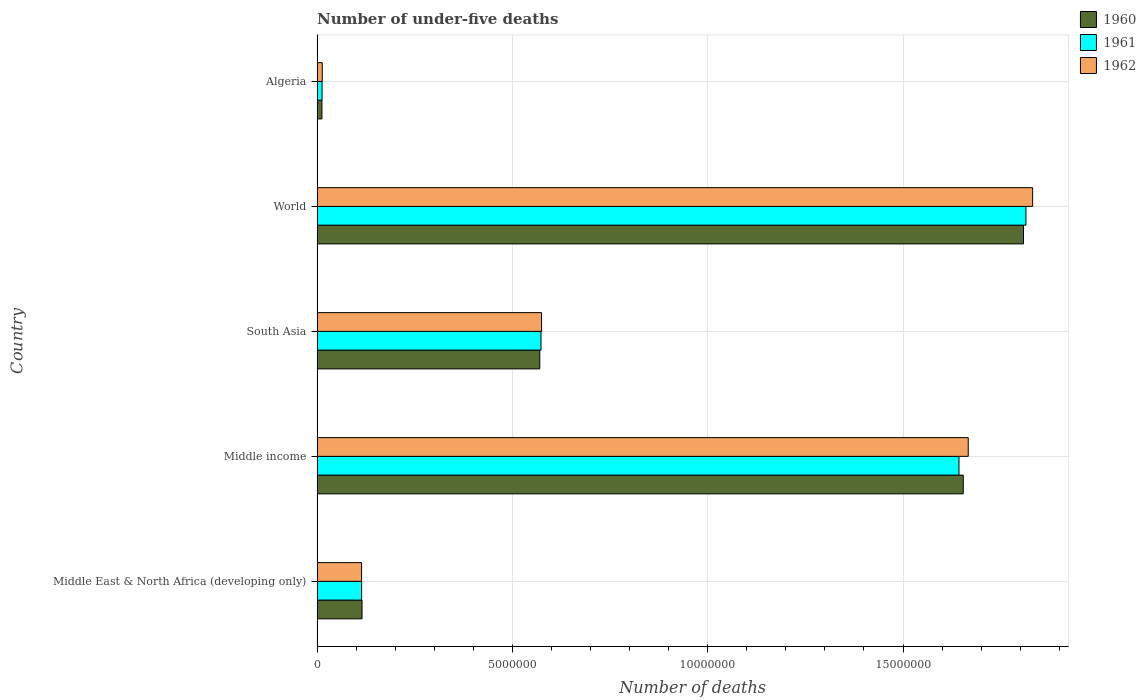How many groups of bars are there?
Make the answer very short. 5. Are the number of bars per tick equal to the number of legend labels?
Make the answer very short. Yes. How many bars are there on the 2nd tick from the top?
Offer a terse response. 3. What is the label of the 1st group of bars from the top?
Your answer should be compact. Algeria. In how many cases, is the number of bars for a given country not equal to the number of legend labels?
Keep it short and to the point. 0. What is the number of under-five deaths in 1961 in South Asia?
Offer a terse response. 5.73e+06. Across all countries, what is the maximum number of under-five deaths in 1960?
Your answer should be very brief. 1.81e+07. Across all countries, what is the minimum number of under-five deaths in 1962?
Keep it short and to the point. 1.33e+05. In which country was the number of under-five deaths in 1961 maximum?
Provide a succinct answer. World. In which country was the number of under-five deaths in 1960 minimum?
Offer a very short reply. Algeria. What is the total number of under-five deaths in 1960 in the graph?
Provide a short and direct response. 4.16e+07. What is the difference between the number of under-five deaths in 1962 in Middle East & North Africa (developing only) and that in South Asia?
Your answer should be very brief. -4.61e+06. What is the difference between the number of under-five deaths in 1962 in Middle East & North Africa (developing only) and the number of under-five deaths in 1961 in World?
Provide a short and direct response. -1.70e+07. What is the average number of under-five deaths in 1961 per country?
Your answer should be compact. 8.32e+06. What is the difference between the number of under-five deaths in 1961 and number of under-five deaths in 1960 in Algeria?
Give a very brief answer. 2789. In how many countries, is the number of under-five deaths in 1962 greater than 8000000 ?
Ensure brevity in your answer.  2. What is the ratio of the number of under-five deaths in 1962 in Algeria to that in World?
Ensure brevity in your answer.  0.01. Is the number of under-five deaths in 1962 in Algeria less than that in South Asia?
Offer a terse response. Yes. What is the difference between the highest and the second highest number of under-five deaths in 1962?
Give a very brief answer. 1.65e+06. What is the difference between the highest and the lowest number of under-five deaths in 1960?
Your answer should be very brief. 1.80e+07. What does the 3rd bar from the bottom in Algeria represents?
Make the answer very short. 1962. Is it the case that in every country, the sum of the number of under-five deaths in 1962 and number of under-five deaths in 1961 is greater than the number of under-five deaths in 1960?
Your answer should be very brief. Yes. How many countries are there in the graph?
Give a very brief answer. 5. What is the difference between two consecutive major ticks on the X-axis?
Offer a terse response. 5.00e+06. Are the values on the major ticks of X-axis written in scientific E-notation?
Offer a terse response. No. Does the graph contain any zero values?
Provide a short and direct response. No. Does the graph contain grids?
Your response must be concise. Yes. How many legend labels are there?
Keep it short and to the point. 3. How are the legend labels stacked?
Ensure brevity in your answer.  Vertical. What is the title of the graph?
Your response must be concise. Number of under-five deaths. What is the label or title of the X-axis?
Your answer should be very brief. Number of deaths. What is the label or title of the Y-axis?
Your response must be concise. Country. What is the Number of deaths in 1960 in Middle East & North Africa (developing only)?
Keep it short and to the point. 1.15e+06. What is the Number of deaths of 1961 in Middle East & North Africa (developing only)?
Give a very brief answer. 1.14e+06. What is the Number of deaths of 1962 in Middle East & North Africa (developing only)?
Provide a succinct answer. 1.14e+06. What is the Number of deaths of 1960 in Middle income?
Provide a succinct answer. 1.65e+07. What is the Number of deaths of 1961 in Middle income?
Offer a terse response. 1.64e+07. What is the Number of deaths in 1962 in Middle income?
Your answer should be compact. 1.67e+07. What is the Number of deaths of 1960 in South Asia?
Make the answer very short. 5.70e+06. What is the Number of deaths in 1961 in South Asia?
Your response must be concise. 5.73e+06. What is the Number of deaths in 1962 in South Asia?
Offer a very short reply. 5.75e+06. What is the Number of deaths of 1960 in World?
Your answer should be compact. 1.81e+07. What is the Number of deaths in 1961 in World?
Give a very brief answer. 1.81e+07. What is the Number of deaths in 1962 in World?
Ensure brevity in your answer.  1.83e+07. What is the Number of deaths of 1960 in Algeria?
Ensure brevity in your answer.  1.25e+05. What is the Number of deaths of 1961 in Algeria?
Your answer should be compact. 1.28e+05. What is the Number of deaths of 1962 in Algeria?
Give a very brief answer. 1.33e+05. Across all countries, what is the maximum Number of deaths in 1960?
Your answer should be compact. 1.81e+07. Across all countries, what is the maximum Number of deaths of 1961?
Provide a short and direct response. 1.81e+07. Across all countries, what is the maximum Number of deaths in 1962?
Your answer should be compact. 1.83e+07. Across all countries, what is the minimum Number of deaths of 1960?
Your answer should be compact. 1.25e+05. Across all countries, what is the minimum Number of deaths in 1961?
Provide a succinct answer. 1.28e+05. Across all countries, what is the minimum Number of deaths of 1962?
Provide a short and direct response. 1.33e+05. What is the total Number of deaths of 1960 in the graph?
Offer a terse response. 4.16e+07. What is the total Number of deaths in 1961 in the graph?
Offer a terse response. 4.16e+07. What is the total Number of deaths in 1962 in the graph?
Provide a short and direct response. 4.20e+07. What is the difference between the Number of deaths of 1960 in Middle East & North Africa (developing only) and that in Middle income?
Provide a short and direct response. -1.54e+07. What is the difference between the Number of deaths in 1961 in Middle East & North Africa (developing only) and that in Middle income?
Provide a short and direct response. -1.53e+07. What is the difference between the Number of deaths in 1962 in Middle East & North Africa (developing only) and that in Middle income?
Provide a short and direct response. -1.55e+07. What is the difference between the Number of deaths in 1960 in Middle East & North Africa (developing only) and that in South Asia?
Ensure brevity in your answer.  -4.55e+06. What is the difference between the Number of deaths in 1961 in Middle East & North Africa (developing only) and that in South Asia?
Your answer should be compact. -4.59e+06. What is the difference between the Number of deaths of 1962 in Middle East & North Africa (developing only) and that in South Asia?
Your answer should be compact. -4.61e+06. What is the difference between the Number of deaths of 1960 in Middle East & North Africa (developing only) and that in World?
Offer a terse response. -1.69e+07. What is the difference between the Number of deaths in 1961 in Middle East & North Africa (developing only) and that in World?
Your response must be concise. -1.70e+07. What is the difference between the Number of deaths of 1962 in Middle East & North Africa (developing only) and that in World?
Make the answer very short. -1.72e+07. What is the difference between the Number of deaths in 1960 in Middle East & North Africa (developing only) and that in Algeria?
Provide a short and direct response. 1.03e+06. What is the difference between the Number of deaths of 1961 in Middle East & North Africa (developing only) and that in Algeria?
Your answer should be compact. 1.01e+06. What is the difference between the Number of deaths in 1962 in Middle East & North Africa (developing only) and that in Algeria?
Keep it short and to the point. 1.01e+06. What is the difference between the Number of deaths in 1960 in Middle income and that in South Asia?
Make the answer very short. 1.08e+07. What is the difference between the Number of deaths of 1961 in Middle income and that in South Asia?
Make the answer very short. 1.07e+07. What is the difference between the Number of deaths in 1962 in Middle income and that in South Asia?
Your response must be concise. 1.09e+07. What is the difference between the Number of deaths of 1960 in Middle income and that in World?
Offer a very short reply. -1.54e+06. What is the difference between the Number of deaths in 1961 in Middle income and that in World?
Provide a short and direct response. -1.71e+06. What is the difference between the Number of deaths of 1962 in Middle income and that in World?
Keep it short and to the point. -1.65e+06. What is the difference between the Number of deaths in 1960 in Middle income and that in Algeria?
Keep it short and to the point. 1.64e+07. What is the difference between the Number of deaths in 1961 in Middle income and that in Algeria?
Your answer should be compact. 1.63e+07. What is the difference between the Number of deaths of 1962 in Middle income and that in Algeria?
Ensure brevity in your answer.  1.65e+07. What is the difference between the Number of deaths in 1960 in South Asia and that in World?
Provide a succinct answer. -1.24e+07. What is the difference between the Number of deaths in 1961 in South Asia and that in World?
Give a very brief answer. -1.24e+07. What is the difference between the Number of deaths in 1962 in South Asia and that in World?
Your answer should be compact. -1.26e+07. What is the difference between the Number of deaths in 1960 in South Asia and that in Algeria?
Ensure brevity in your answer.  5.58e+06. What is the difference between the Number of deaths in 1961 in South Asia and that in Algeria?
Provide a short and direct response. 5.60e+06. What is the difference between the Number of deaths in 1962 in South Asia and that in Algeria?
Offer a terse response. 5.61e+06. What is the difference between the Number of deaths of 1960 in World and that in Algeria?
Give a very brief answer. 1.80e+07. What is the difference between the Number of deaths in 1961 in World and that in Algeria?
Give a very brief answer. 1.80e+07. What is the difference between the Number of deaths in 1962 in World and that in Algeria?
Make the answer very short. 1.82e+07. What is the difference between the Number of deaths in 1960 in Middle East & North Africa (developing only) and the Number of deaths in 1961 in Middle income?
Your answer should be very brief. -1.53e+07. What is the difference between the Number of deaths in 1960 in Middle East & North Africa (developing only) and the Number of deaths in 1962 in Middle income?
Make the answer very short. -1.55e+07. What is the difference between the Number of deaths of 1961 in Middle East & North Africa (developing only) and the Number of deaths of 1962 in Middle income?
Offer a very short reply. -1.55e+07. What is the difference between the Number of deaths in 1960 in Middle East & North Africa (developing only) and the Number of deaths in 1961 in South Asia?
Give a very brief answer. -4.58e+06. What is the difference between the Number of deaths of 1960 in Middle East & North Africa (developing only) and the Number of deaths of 1962 in South Asia?
Make the answer very short. -4.59e+06. What is the difference between the Number of deaths of 1961 in Middle East & North Africa (developing only) and the Number of deaths of 1962 in South Asia?
Provide a succinct answer. -4.61e+06. What is the difference between the Number of deaths in 1960 in Middle East & North Africa (developing only) and the Number of deaths in 1961 in World?
Offer a very short reply. -1.70e+07. What is the difference between the Number of deaths in 1960 in Middle East & North Africa (developing only) and the Number of deaths in 1962 in World?
Your answer should be compact. -1.72e+07. What is the difference between the Number of deaths of 1961 in Middle East & North Africa (developing only) and the Number of deaths of 1962 in World?
Give a very brief answer. -1.72e+07. What is the difference between the Number of deaths in 1960 in Middle East & North Africa (developing only) and the Number of deaths in 1961 in Algeria?
Make the answer very short. 1.02e+06. What is the difference between the Number of deaths in 1960 in Middle East & North Africa (developing only) and the Number of deaths in 1962 in Algeria?
Keep it short and to the point. 1.02e+06. What is the difference between the Number of deaths in 1961 in Middle East & North Africa (developing only) and the Number of deaths in 1962 in Algeria?
Provide a succinct answer. 1.01e+06. What is the difference between the Number of deaths in 1960 in Middle income and the Number of deaths in 1961 in South Asia?
Offer a very short reply. 1.08e+07. What is the difference between the Number of deaths in 1960 in Middle income and the Number of deaths in 1962 in South Asia?
Your answer should be very brief. 1.08e+07. What is the difference between the Number of deaths in 1961 in Middle income and the Number of deaths in 1962 in South Asia?
Provide a short and direct response. 1.07e+07. What is the difference between the Number of deaths of 1960 in Middle income and the Number of deaths of 1961 in World?
Offer a terse response. -1.60e+06. What is the difference between the Number of deaths of 1960 in Middle income and the Number of deaths of 1962 in World?
Your answer should be very brief. -1.78e+06. What is the difference between the Number of deaths of 1961 in Middle income and the Number of deaths of 1962 in World?
Your answer should be very brief. -1.89e+06. What is the difference between the Number of deaths of 1960 in Middle income and the Number of deaths of 1961 in Algeria?
Make the answer very short. 1.64e+07. What is the difference between the Number of deaths of 1960 in Middle income and the Number of deaths of 1962 in Algeria?
Provide a succinct answer. 1.64e+07. What is the difference between the Number of deaths of 1961 in Middle income and the Number of deaths of 1962 in Algeria?
Keep it short and to the point. 1.63e+07. What is the difference between the Number of deaths of 1960 in South Asia and the Number of deaths of 1961 in World?
Provide a short and direct response. -1.24e+07. What is the difference between the Number of deaths of 1960 in South Asia and the Number of deaths of 1962 in World?
Offer a very short reply. -1.26e+07. What is the difference between the Number of deaths in 1961 in South Asia and the Number of deaths in 1962 in World?
Keep it short and to the point. -1.26e+07. What is the difference between the Number of deaths of 1960 in South Asia and the Number of deaths of 1961 in Algeria?
Give a very brief answer. 5.57e+06. What is the difference between the Number of deaths of 1960 in South Asia and the Number of deaths of 1962 in Algeria?
Ensure brevity in your answer.  5.57e+06. What is the difference between the Number of deaths of 1961 in South Asia and the Number of deaths of 1962 in Algeria?
Ensure brevity in your answer.  5.60e+06. What is the difference between the Number of deaths of 1960 in World and the Number of deaths of 1961 in Algeria?
Provide a succinct answer. 1.80e+07. What is the difference between the Number of deaths in 1960 in World and the Number of deaths in 1962 in Algeria?
Provide a short and direct response. 1.80e+07. What is the difference between the Number of deaths of 1961 in World and the Number of deaths of 1962 in Algeria?
Keep it short and to the point. 1.80e+07. What is the average Number of deaths of 1960 per country?
Ensure brevity in your answer.  8.32e+06. What is the average Number of deaths of 1961 per country?
Provide a succinct answer. 8.32e+06. What is the average Number of deaths in 1962 per country?
Ensure brevity in your answer.  8.40e+06. What is the difference between the Number of deaths in 1960 and Number of deaths in 1961 in Middle East & North Africa (developing only)?
Your answer should be compact. 1.05e+04. What is the difference between the Number of deaths in 1960 and Number of deaths in 1962 in Middle East & North Africa (developing only)?
Provide a succinct answer. 1.18e+04. What is the difference between the Number of deaths in 1961 and Number of deaths in 1962 in Middle East & North Africa (developing only)?
Make the answer very short. 1336. What is the difference between the Number of deaths of 1960 and Number of deaths of 1961 in Middle income?
Your answer should be very brief. 1.10e+05. What is the difference between the Number of deaths of 1960 and Number of deaths of 1962 in Middle income?
Keep it short and to the point. -1.27e+05. What is the difference between the Number of deaths in 1961 and Number of deaths in 1962 in Middle income?
Provide a short and direct response. -2.37e+05. What is the difference between the Number of deaths of 1960 and Number of deaths of 1961 in South Asia?
Your response must be concise. -3.16e+04. What is the difference between the Number of deaths in 1960 and Number of deaths in 1962 in South Asia?
Offer a terse response. -4.54e+04. What is the difference between the Number of deaths in 1961 and Number of deaths in 1962 in South Asia?
Provide a short and direct response. -1.37e+04. What is the difference between the Number of deaths in 1960 and Number of deaths in 1961 in World?
Keep it short and to the point. -6.21e+04. What is the difference between the Number of deaths in 1960 and Number of deaths in 1962 in World?
Offer a very short reply. -2.34e+05. What is the difference between the Number of deaths in 1961 and Number of deaths in 1962 in World?
Your answer should be very brief. -1.72e+05. What is the difference between the Number of deaths in 1960 and Number of deaths in 1961 in Algeria?
Give a very brief answer. -2789. What is the difference between the Number of deaths in 1960 and Number of deaths in 1962 in Algeria?
Make the answer very short. -7580. What is the difference between the Number of deaths of 1961 and Number of deaths of 1962 in Algeria?
Make the answer very short. -4791. What is the ratio of the Number of deaths in 1960 in Middle East & North Africa (developing only) to that in Middle income?
Your response must be concise. 0.07. What is the ratio of the Number of deaths in 1961 in Middle East & North Africa (developing only) to that in Middle income?
Your response must be concise. 0.07. What is the ratio of the Number of deaths of 1962 in Middle East & North Africa (developing only) to that in Middle income?
Provide a short and direct response. 0.07. What is the ratio of the Number of deaths of 1960 in Middle East & North Africa (developing only) to that in South Asia?
Your answer should be compact. 0.2. What is the ratio of the Number of deaths in 1961 in Middle East & North Africa (developing only) to that in South Asia?
Offer a very short reply. 0.2. What is the ratio of the Number of deaths of 1962 in Middle East & North Africa (developing only) to that in South Asia?
Provide a short and direct response. 0.2. What is the ratio of the Number of deaths of 1960 in Middle East & North Africa (developing only) to that in World?
Your answer should be very brief. 0.06. What is the ratio of the Number of deaths of 1961 in Middle East & North Africa (developing only) to that in World?
Offer a very short reply. 0.06. What is the ratio of the Number of deaths in 1962 in Middle East & North Africa (developing only) to that in World?
Make the answer very short. 0.06. What is the ratio of the Number of deaths in 1960 in Middle East & North Africa (developing only) to that in Algeria?
Your answer should be compact. 9.18. What is the ratio of the Number of deaths of 1961 in Middle East & North Africa (developing only) to that in Algeria?
Provide a short and direct response. 8.9. What is the ratio of the Number of deaths of 1962 in Middle East & North Africa (developing only) to that in Algeria?
Give a very brief answer. 8.57. What is the ratio of the Number of deaths of 1960 in Middle income to that in South Asia?
Your answer should be compact. 2.9. What is the ratio of the Number of deaths in 1961 in Middle income to that in South Asia?
Provide a succinct answer. 2.87. What is the ratio of the Number of deaths of 1962 in Middle income to that in South Asia?
Ensure brevity in your answer.  2.9. What is the ratio of the Number of deaths of 1960 in Middle income to that in World?
Provide a short and direct response. 0.91. What is the ratio of the Number of deaths of 1961 in Middle income to that in World?
Offer a very short reply. 0.91. What is the ratio of the Number of deaths in 1962 in Middle income to that in World?
Offer a terse response. 0.91. What is the ratio of the Number of deaths of 1960 in Middle income to that in Algeria?
Your response must be concise. 131.85. What is the ratio of the Number of deaths of 1961 in Middle income to that in Algeria?
Provide a short and direct response. 128.13. What is the ratio of the Number of deaths in 1962 in Middle income to that in Algeria?
Keep it short and to the point. 125.3. What is the ratio of the Number of deaths of 1960 in South Asia to that in World?
Give a very brief answer. 0.32. What is the ratio of the Number of deaths of 1961 in South Asia to that in World?
Ensure brevity in your answer.  0.32. What is the ratio of the Number of deaths of 1962 in South Asia to that in World?
Ensure brevity in your answer.  0.31. What is the ratio of the Number of deaths in 1960 in South Asia to that in Algeria?
Your answer should be compact. 45.45. What is the ratio of the Number of deaths in 1961 in South Asia to that in Algeria?
Make the answer very short. 44.7. What is the ratio of the Number of deaths of 1962 in South Asia to that in Algeria?
Provide a short and direct response. 43.2. What is the ratio of the Number of deaths of 1960 in World to that in Algeria?
Provide a short and direct response. 144.14. What is the ratio of the Number of deaths of 1961 in World to that in Algeria?
Offer a terse response. 141.49. What is the ratio of the Number of deaths in 1962 in World to that in Algeria?
Your response must be concise. 137.69. What is the difference between the highest and the second highest Number of deaths of 1960?
Your answer should be compact. 1.54e+06. What is the difference between the highest and the second highest Number of deaths in 1961?
Provide a succinct answer. 1.71e+06. What is the difference between the highest and the second highest Number of deaths in 1962?
Your response must be concise. 1.65e+06. What is the difference between the highest and the lowest Number of deaths in 1960?
Provide a short and direct response. 1.80e+07. What is the difference between the highest and the lowest Number of deaths in 1961?
Provide a succinct answer. 1.80e+07. What is the difference between the highest and the lowest Number of deaths of 1962?
Your answer should be compact. 1.82e+07. 